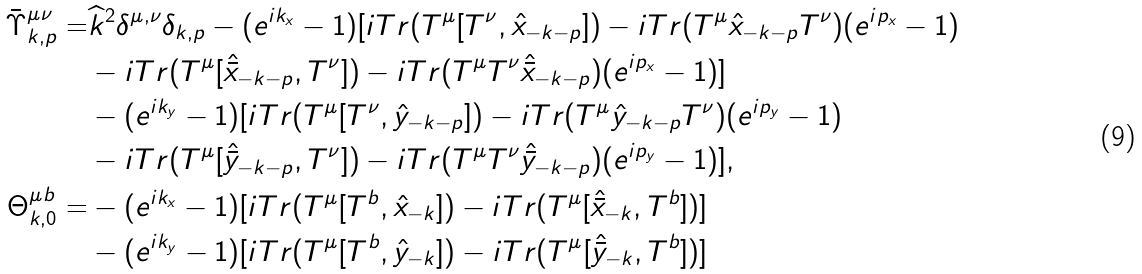<formula> <loc_0><loc_0><loc_500><loc_500>\bar { \Upsilon } _ { k , p } ^ { \mu \nu } = & \widehat { k } ^ { 2 } \delta ^ { \mu , \nu } \delta _ { k , p } - ( e ^ { i k _ { x } } - 1 ) [ i T r ( T ^ { \mu } [ T ^ { \nu } , \hat { x } _ { - k - p } ] ) - i T r ( T ^ { \mu } \hat { x } _ { - k - p } T ^ { \nu } ) ( e ^ { i p _ { x } } - 1 ) \\ & - i T r ( T ^ { \mu } [ \hat { \bar { x } } _ { - k - p } , T ^ { \nu } ] ) - i T r ( T ^ { \mu } T ^ { \nu } \hat { \bar { x } } _ { - k - p } ) ( e ^ { i p _ { x } } - 1 ) ] \\ & - ( e ^ { i k _ { y } } - 1 ) [ i T r ( T ^ { \mu } [ T ^ { \nu } , \hat { y } _ { - k - p } ] ) - i T r ( T ^ { \mu } \hat { y } _ { - k - p } T ^ { \nu } ) ( e ^ { i p _ { y } } - 1 ) \\ & - i T r ( T ^ { \mu } [ \hat { \bar { y } } _ { - k - p } , T ^ { \nu } ] ) - i T r ( T ^ { \mu } T ^ { \nu } \hat { \bar { y } } _ { - k - p } ) ( e ^ { i p _ { y } } - 1 ) ] , \\ \Theta _ { k , 0 } ^ { \mu b } = & - ( e ^ { i k _ { x } } - 1 ) [ i T r ( T ^ { \mu } [ T ^ { b } , \hat { x } _ { - k } ] ) - i T r ( T ^ { \mu } [ \hat { \bar { x } } _ { - k } , T ^ { b } ] ) ] \\ & - ( e ^ { i k _ { y } } - 1 ) [ i T r ( T ^ { \mu } [ T ^ { b } , \hat { y } _ { - k } ] ) - i T r ( T ^ { \mu } [ \hat { \bar { y } } _ { - k } , T ^ { b } ] ) ]</formula> 